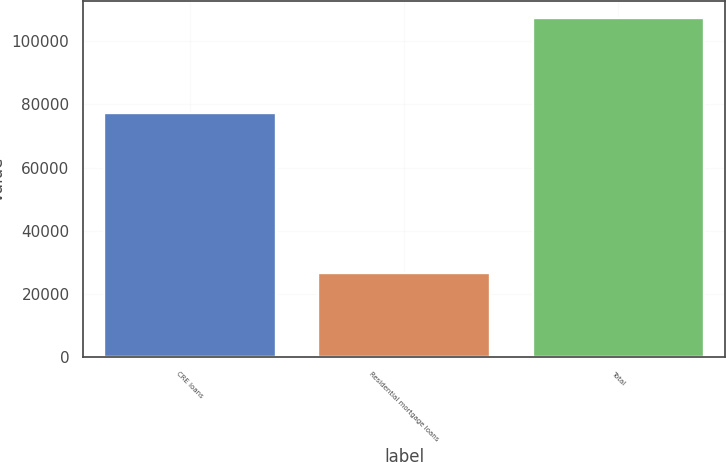Convert chart to OTSL. <chart><loc_0><loc_0><loc_500><loc_500><bar_chart><fcel>CRE loans<fcel>Residential mortgage loans<fcel>Total<nl><fcel>77316<fcel>26686<fcel>107224<nl></chart> 